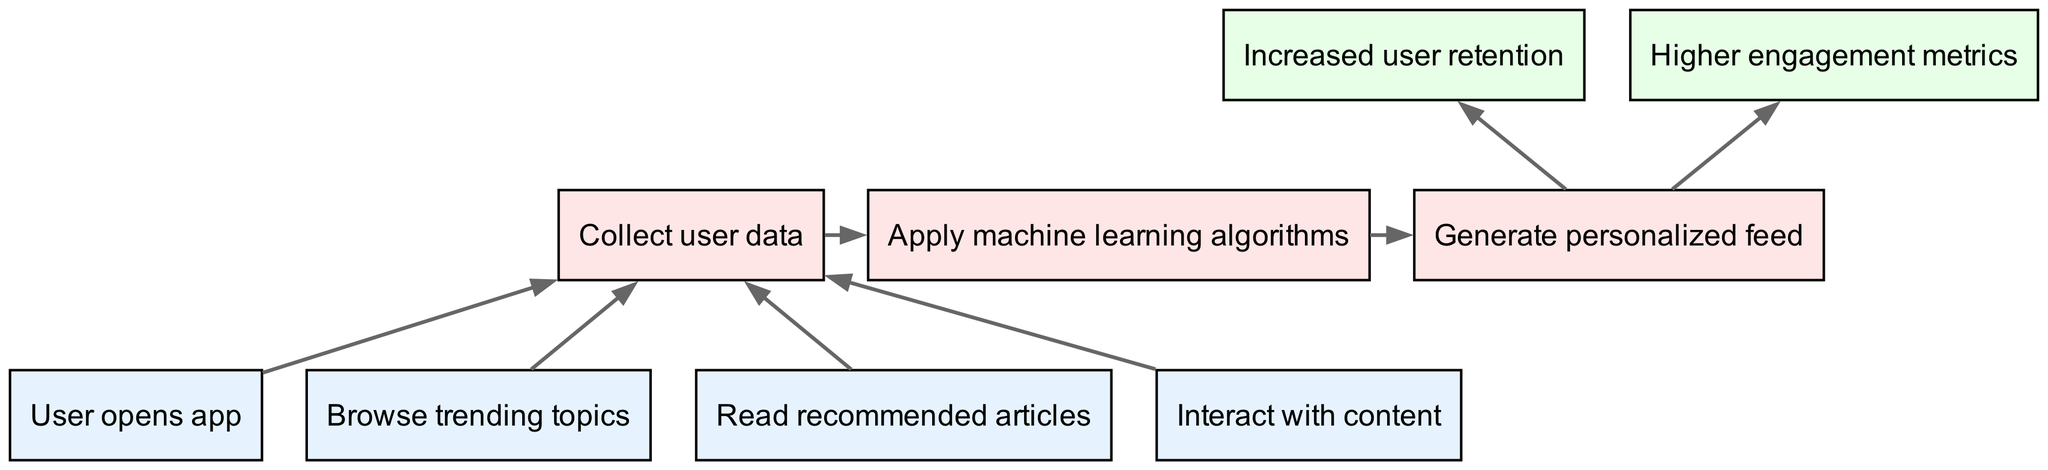What are the bottom nodes in the diagram? The bottom nodes consist of the starting points in the user engagement funnel and are listed directly in the diagram. The bottom nodes include "User opens app", "Browse trending topics", "Read recommended articles", and "Interact with content".
Answer: User opens app, Browse trending topics, Read recommended articles, Interact with content How many middle nodes are present? The number of middle nodes is determined by counting the nodes labeled in that section of the diagram. There are three middle nodes which are "Collect user data", "Apply machine learning algorithms", and "Generate personalized feed".
Answer: 3 What is the final output of the engagement funnel? The final outputs of the funnel indicate the desired outcomes of increased user engagement and are labeled as the top nodes. They are "Increased user retention" and "Higher engagement metrics".
Answer: Increased user retention, Higher engagement metrics Which node directly follows "Collect user data"? The flow of the diagram indicates which nodes come after others. Following "Collect user data", the next node in the sequence is "Apply machine learning algorithms".
Answer: Apply machine learning algorithms How many edges are there in total? The total number of edges is calculated by counting the directed connections shown between the nodes in the diagram. There are eight edges that illustrate the flow between nodes.
Answer: 8 What do the top nodes signify in the context of the diagram? The top nodes represent the ultimate goals of the user engagement funnel, indicating the success metrics that the recommendation engine aims to achieve based on user interaction. They show the expected outcomes of the entire process.
Answer: Increased user retention, Higher engagement metrics What is the relationship between "Generate personalized feed" and the top nodes? The diagram indicates that the "Generate personalized feed" node flows directly into both of the top nodes, meaning that the feed generation is critical for achieving the engagement objectives stated at the top of the diagram.
Answer: It leads to increased user retention and higher engagement metrics What is the purpose of the "Interact with content" node? The "Interact with content" node plays a role in facilitating user engagement, as it denotes active participation by users, which contributes to collecting user data and boosting the effectiveness of personalized recommendations.
Answer: To enhance user engagement 